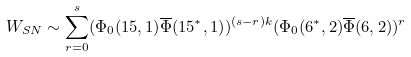Convert formula to latex. <formula><loc_0><loc_0><loc_500><loc_500>W _ { S N } \sim \sum _ { r = 0 } ^ { s } ( \Phi _ { 0 } { ( 1 5 , 1 ) } { \overline { \Phi } } { ( 1 5 ^ { * } , 1 ) } ) ^ { ( s - r ) k } ( \Phi _ { 0 } { ( 6 ^ { * } , 2 ) } { \overline { \Phi } } { ( 6 , 2 ) } ) ^ { r }</formula> 